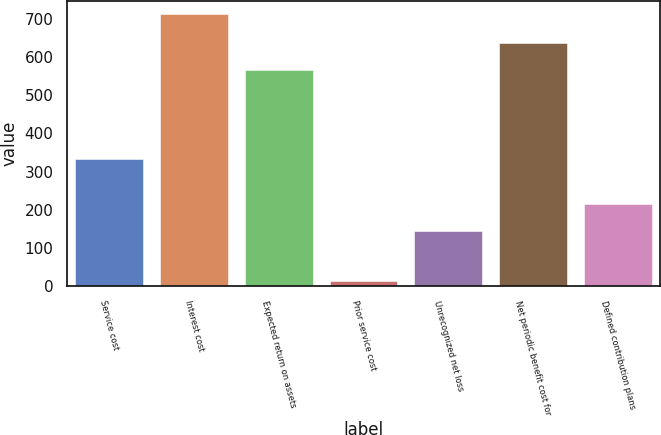Convert chart. <chart><loc_0><loc_0><loc_500><loc_500><bar_chart><fcel>Service cost<fcel>Interest cost<fcel>Expected return on assets<fcel>Prior service cost<fcel>Unrecognized net loss<fcel>Net periodic benefit cost for<fcel>Defined contribution plans<nl><fcel>333<fcel>712<fcel>566<fcel>13<fcel>145<fcel>637<fcel>214.9<nl></chart> 